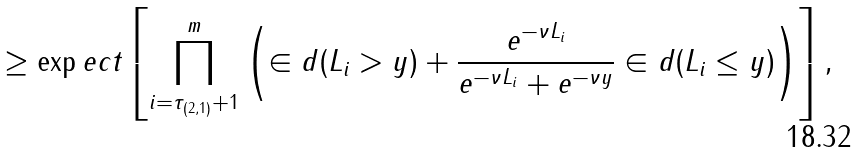<formula> <loc_0><loc_0><loc_500><loc_500>& \geq \exp e c t \left [ \prod _ { i = \tau _ { ( 2 , 1 ) } + 1 } ^ { m } \left ( \in d ( L _ { i } > y ) + \frac { e ^ { - \nu L _ { i } } } { e ^ { - \nu L _ { i } } + e ^ { - \nu y } } \in d ( L _ { i } \leq y ) \right ) \right ] ,</formula> 